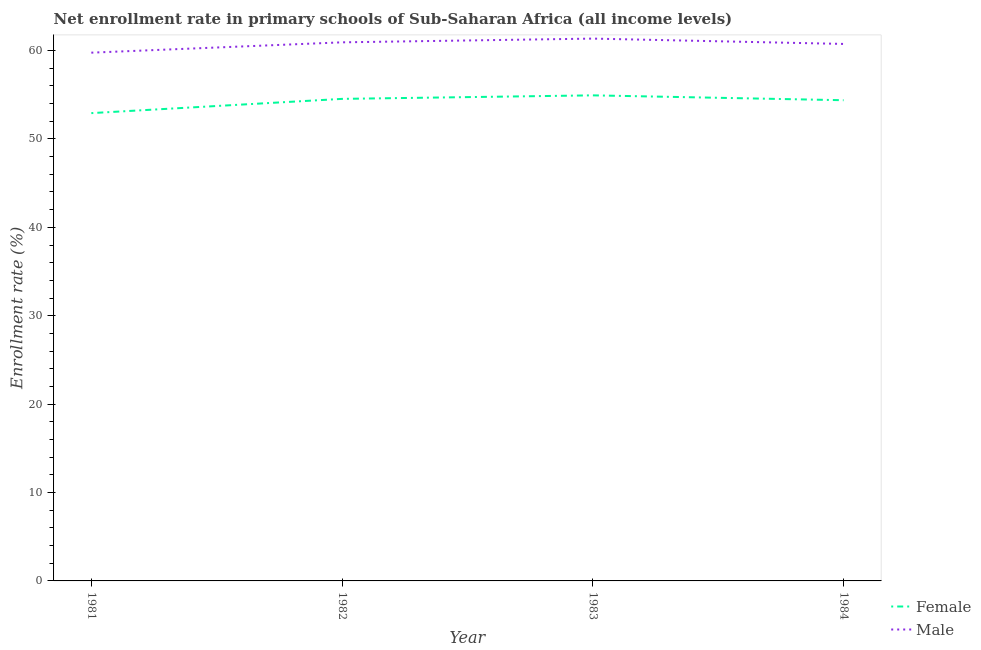How many different coloured lines are there?
Provide a succinct answer. 2. Is the number of lines equal to the number of legend labels?
Provide a short and direct response. Yes. What is the enrollment rate of male students in 1981?
Your answer should be very brief. 59.76. Across all years, what is the maximum enrollment rate of male students?
Make the answer very short. 61.35. Across all years, what is the minimum enrollment rate of male students?
Provide a short and direct response. 59.76. In which year was the enrollment rate of male students maximum?
Provide a succinct answer. 1983. In which year was the enrollment rate of female students minimum?
Provide a succinct answer. 1981. What is the total enrollment rate of male students in the graph?
Your answer should be very brief. 242.78. What is the difference between the enrollment rate of female students in 1981 and that in 1984?
Offer a very short reply. -1.46. What is the difference between the enrollment rate of male students in 1982 and the enrollment rate of female students in 1984?
Offer a terse response. 6.55. What is the average enrollment rate of male students per year?
Make the answer very short. 60.69. In the year 1984, what is the difference between the enrollment rate of male students and enrollment rate of female students?
Offer a terse response. 6.37. What is the ratio of the enrollment rate of male students in 1981 to that in 1982?
Your answer should be very brief. 0.98. Is the difference between the enrollment rate of female students in 1981 and 1983 greater than the difference between the enrollment rate of male students in 1981 and 1983?
Ensure brevity in your answer.  No. What is the difference between the highest and the second highest enrollment rate of female students?
Offer a very short reply. 0.4. What is the difference between the highest and the lowest enrollment rate of male students?
Your answer should be compact. 1.59. Is the enrollment rate of female students strictly greater than the enrollment rate of male students over the years?
Give a very brief answer. No. How many lines are there?
Make the answer very short. 2. Are the values on the major ticks of Y-axis written in scientific E-notation?
Your answer should be very brief. No. How many legend labels are there?
Make the answer very short. 2. How are the legend labels stacked?
Give a very brief answer. Vertical. What is the title of the graph?
Offer a very short reply. Net enrollment rate in primary schools of Sub-Saharan Africa (all income levels). Does "Under-5(female)" appear as one of the legend labels in the graph?
Give a very brief answer. No. What is the label or title of the Y-axis?
Ensure brevity in your answer.  Enrollment rate (%). What is the Enrollment rate (%) of Female in 1981?
Provide a succinct answer. 52.92. What is the Enrollment rate (%) in Male in 1981?
Your answer should be compact. 59.76. What is the Enrollment rate (%) in Female in 1982?
Your response must be concise. 54.53. What is the Enrollment rate (%) of Male in 1982?
Provide a succinct answer. 60.93. What is the Enrollment rate (%) in Female in 1983?
Your answer should be very brief. 54.93. What is the Enrollment rate (%) in Male in 1983?
Provide a succinct answer. 61.35. What is the Enrollment rate (%) of Female in 1984?
Your answer should be compact. 54.38. What is the Enrollment rate (%) of Male in 1984?
Offer a terse response. 60.74. Across all years, what is the maximum Enrollment rate (%) of Female?
Provide a short and direct response. 54.93. Across all years, what is the maximum Enrollment rate (%) in Male?
Your response must be concise. 61.35. Across all years, what is the minimum Enrollment rate (%) of Female?
Give a very brief answer. 52.92. Across all years, what is the minimum Enrollment rate (%) in Male?
Your answer should be compact. 59.76. What is the total Enrollment rate (%) in Female in the graph?
Offer a very short reply. 216.76. What is the total Enrollment rate (%) in Male in the graph?
Provide a short and direct response. 242.78. What is the difference between the Enrollment rate (%) in Female in 1981 and that in 1982?
Ensure brevity in your answer.  -1.61. What is the difference between the Enrollment rate (%) in Male in 1981 and that in 1982?
Offer a very short reply. -1.17. What is the difference between the Enrollment rate (%) of Female in 1981 and that in 1983?
Offer a terse response. -2.01. What is the difference between the Enrollment rate (%) of Male in 1981 and that in 1983?
Ensure brevity in your answer.  -1.59. What is the difference between the Enrollment rate (%) in Female in 1981 and that in 1984?
Provide a succinct answer. -1.46. What is the difference between the Enrollment rate (%) in Male in 1981 and that in 1984?
Your response must be concise. -0.99. What is the difference between the Enrollment rate (%) of Female in 1982 and that in 1983?
Give a very brief answer. -0.4. What is the difference between the Enrollment rate (%) of Male in 1982 and that in 1983?
Your answer should be very brief. -0.42. What is the difference between the Enrollment rate (%) of Female in 1982 and that in 1984?
Make the answer very short. 0.15. What is the difference between the Enrollment rate (%) in Male in 1982 and that in 1984?
Your response must be concise. 0.18. What is the difference between the Enrollment rate (%) in Female in 1983 and that in 1984?
Provide a short and direct response. 0.55. What is the difference between the Enrollment rate (%) of Male in 1983 and that in 1984?
Provide a succinct answer. 0.6. What is the difference between the Enrollment rate (%) of Female in 1981 and the Enrollment rate (%) of Male in 1982?
Offer a very short reply. -8.01. What is the difference between the Enrollment rate (%) of Female in 1981 and the Enrollment rate (%) of Male in 1983?
Give a very brief answer. -8.43. What is the difference between the Enrollment rate (%) in Female in 1981 and the Enrollment rate (%) in Male in 1984?
Offer a terse response. -7.83. What is the difference between the Enrollment rate (%) in Female in 1982 and the Enrollment rate (%) in Male in 1983?
Ensure brevity in your answer.  -6.82. What is the difference between the Enrollment rate (%) of Female in 1982 and the Enrollment rate (%) of Male in 1984?
Your answer should be very brief. -6.21. What is the difference between the Enrollment rate (%) of Female in 1983 and the Enrollment rate (%) of Male in 1984?
Make the answer very short. -5.82. What is the average Enrollment rate (%) of Female per year?
Provide a succinct answer. 54.19. What is the average Enrollment rate (%) in Male per year?
Keep it short and to the point. 60.69. In the year 1981, what is the difference between the Enrollment rate (%) of Female and Enrollment rate (%) of Male?
Offer a terse response. -6.84. In the year 1982, what is the difference between the Enrollment rate (%) of Female and Enrollment rate (%) of Male?
Your response must be concise. -6.4. In the year 1983, what is the difference between the Enrollment rate (%) in Female and Enrollment rate (%) in Male?
Your answer should be very brief. -6.42. In the year 1984, what is the difference between the Enrollment rate (%) in Female and Enrollment rate (%) in Male?
Provide a succinct answer. -6.37. What is the ratio of the Enrollment rate (%) of Female in 1981 to that in 1982?
Give a very brief answer. 0.97. What is the ratio of the Enrollment rate (%) in Male in 1981 to that in 1982?
Provide a succinct answer. 0.98. What is the ratio of the Enrollment rate (%) in Female in 1981 to that in 1983?
Offer a very short reply. 0.96. What is the ratio of the Enrollment rate (%) of Male in 1981 to that in 1983?
Give a very brief answer. 0.97. What is the ratio of the Enrollment rate (%) of Female in 1981 to that in 1984?
Give a very brief answer. 0.97. What is the ratio of the Enrollment rate (%) of Male in 1981 to that in 1984?
Ensure brevity in your answer.  0.98. What is the ratio of the Enrollment rate (%) in Female in 1982 to that in 1984?
Make the answer very short. 1. What is the ratio of the Enrollment rate (%) in Male in 1982 to that in 1984?
Provide a short and direct response. 1. What is the ratio of the Enrollment rate (%) of Male in 1983 to that in 1984?
Your answer should be very brief. 1.01. What is the difference between the highest and the second highest Enrollment rate (%) in Female?
Your answer should be compact. 0.4. What is the difference between the highest and the second highest Enrollment rate (%) of Male?
Provide a succinct answer. 0.42. What is the difference between the highest and the lowest Enrollment rate (%) of Female?
Offer a very short reply. 2.01. What is the difference between the highest and the lowest Enrollment rate (%) in Male?
Your response must be concise. 1.59. 